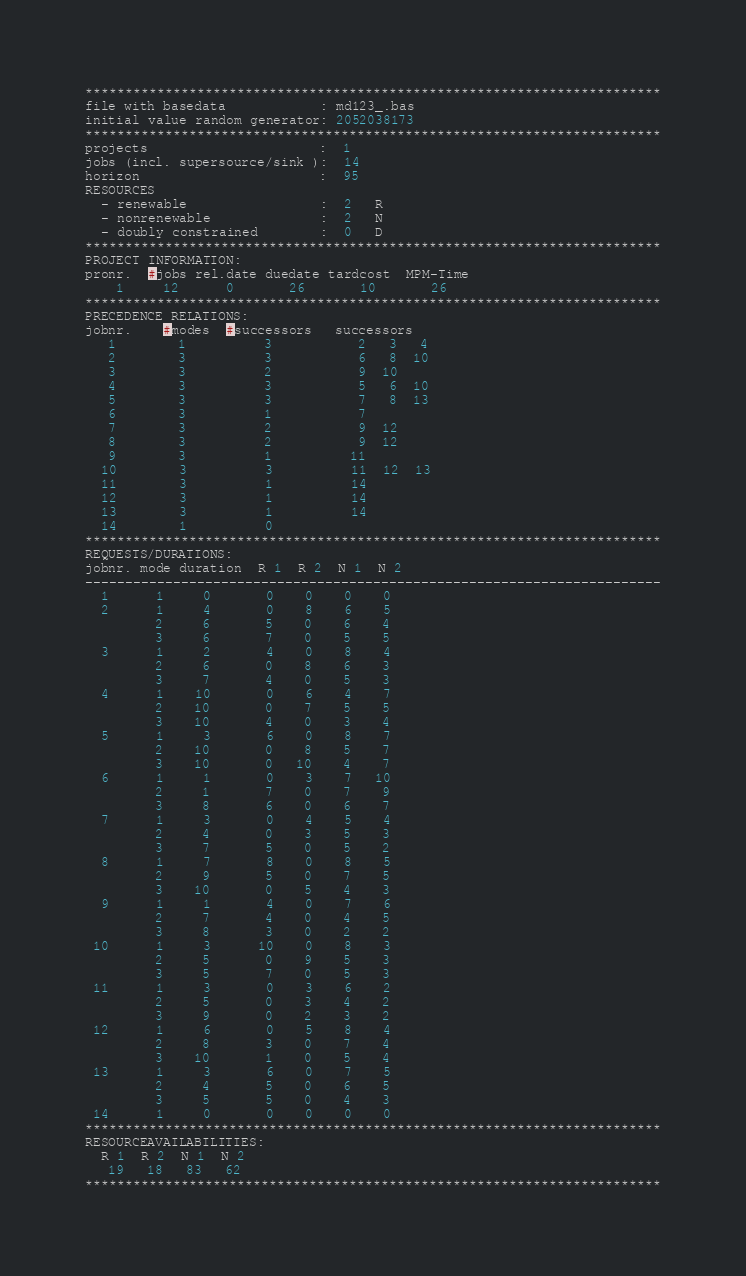Convert code to text. <code><loc_0><loc_0><loc_500><loc_500><_ObjectiveC_>************************************************************************
file with basedata            : md123_.bas
initial value random generator: 2052038173
************************************************************************
projects                      :  1
jobs (incl. supersource/sink ):  14
horizon                       :  95
RESOURCES
  - renewable                 :  2   R
  - nonrenewable              :  2   N
  - doubly constrained        :  0   D
************************************************************************
PROJECT INFORMATION:
pronr.  #jobs rel.date duedate tardcost  MPM-Time
    1     12      0       26       10       26
************************************************************************
PRECEDENCE RELATIONS:
jobnr.    #modes  #successors   successors
   1        1          3           2   3   4
   2        3          3           6   8  10
   3        3          2           9  10
   4        3          3           5   6  10
   5        3          3           7   8  13
   6        3          1           7
   7        3          2           9  12
   8        3          2           9  12
   9        3          1          11
  10        3          3          11  12  13
  11        3          1          14
  12        3          1          14
  13        3          1          14
  14        1          0        
************************************************************************
REQUESTS/DURATIONS:
jobnr. mode duration  R 1  R 2  N 1  N 2
------------------------------------------------------------------------
  1      1     0       0    0    0    0
  2      1     4       0    8    6    5
         2     6       5    0    6    4
         3     6       7    0    5    5
  3      1     2       4    0    8    4
         2     6       0    8    6    3
         3     7       4    0    5    3
  4      1    10       0    6    4    7
         2    10       0    7    5    5
         3    10       4    0    3    4
  5      1     3       6    0    8    7
         2    10       0    8    5    7
         3    10       0   10    4    7
  6      1     1       0    3    7   10
         2     1       7    0    7    9
         3     8       6    0    6    7
  7      1     3       0    4    5    4
         2     4       0    3    5    3
         3     7       5    0    5    2
  8      1     7       8    0    8    5
         2     9       5    0    7    5
         3    10       0    5    4    3
  9      1     1       4    0    7    6
         2     7       4    0    4    5
         3     8       3    0    2    2
 10      1     3      10    0    8    3
         2     5       0    9    5    3
         3     5       7    0    5    3
 11      1     3       0    3    6    2
         2     5       0    3    4    2
         3     9       0    2    3    2
 12      1     6       0    5    8    4
         2     8       3    0    7    4
         3    10       1    0    5    4
 13      1     3       6    0    7    5
         2     4       5    0    6    5
         3     5       5    0    4    3
 14      1     0       0    0    0    0
************************************************************************
RESOURCEAVAILABILITIES:
  R 1  R 2  N 1  N 2
   19   18   83   62
************************************************************************
</code> 